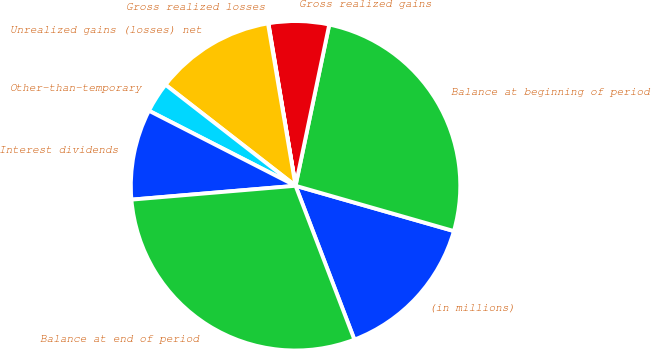Convert chart to OTSL. <chart><loc_0><loc_0><loc_500><loc_500><pie_chart><fcel>(in millions)<fcel>Balance at beginning of period<fcel>Gross realized gains<fcel>Gross realized losses<fcel>Unrealized gains (losses) net<fcel>Other-than-temporary<fcel>Interest dividends<fcel>Balance at end of period<nl><fcel>14.75%<fcel>26.15%<fcel>5.92%<fcel>0.04%<fcel>11.81%<fcel>2.98%<fcel>8.87%<fcel>29.47%<nl></chart> 